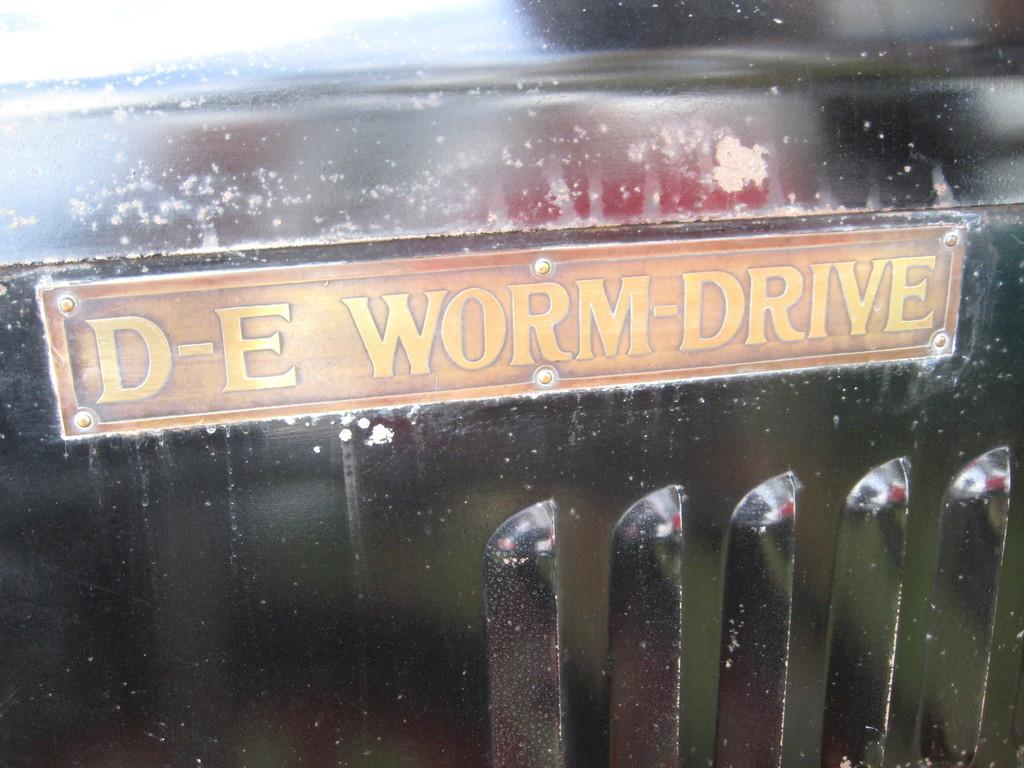What is the color of the object in the image? The object in the image is black-colored. What other prominent feature can be seen in the image? There is an orange and yellow-colored board in the image. What religion is being practiced in the image? There is no indication of any religious practice in the image. What type of magic is being performed in the image? There is no magic or any indication of a magical act in the image. 